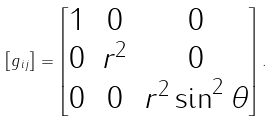<formula> <loc_0><loc_0><loc_500><loc_500>\left [ g _ { i j } \right ] = \begin{bmatrix} 1 & 0 & 0 \\ 0 & r ^ { 2 } & 0 \\ 0 & 0 & r ^ { 2 } \sin ^ { 2 } \theta \\ \end{bmatrix} .</formula> 